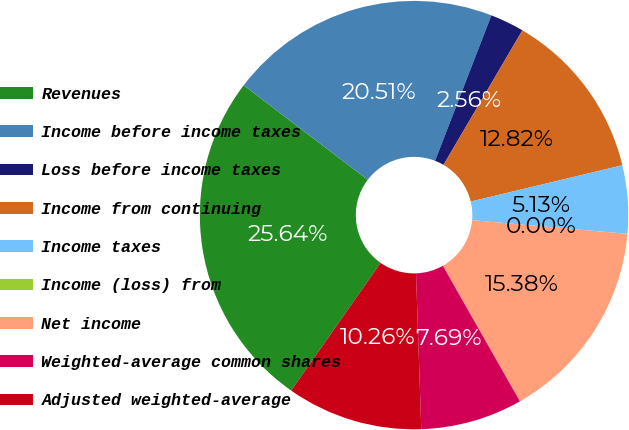<chart> <loc_0><loc_0><loc_500><loc_500><pie_chart><fcel>Revenues<fcel>Income before income taxes<fcel>Loss before income taxes<fcel>Income from continuing<fcel>Income taxes<fcel>Income (loss) from<fcel>Net income<fcel>Weighted-average common shares<fcel>Adjusted weighted-average<nl><fcel>25.64%<fcel>20.51%<fcel>2.56%<fcel>12.82%<fcel>5.13%<fcel>0.0%<fcel>15.38%<fcel>7.69%<fcel>10.26%<nl></chart> 